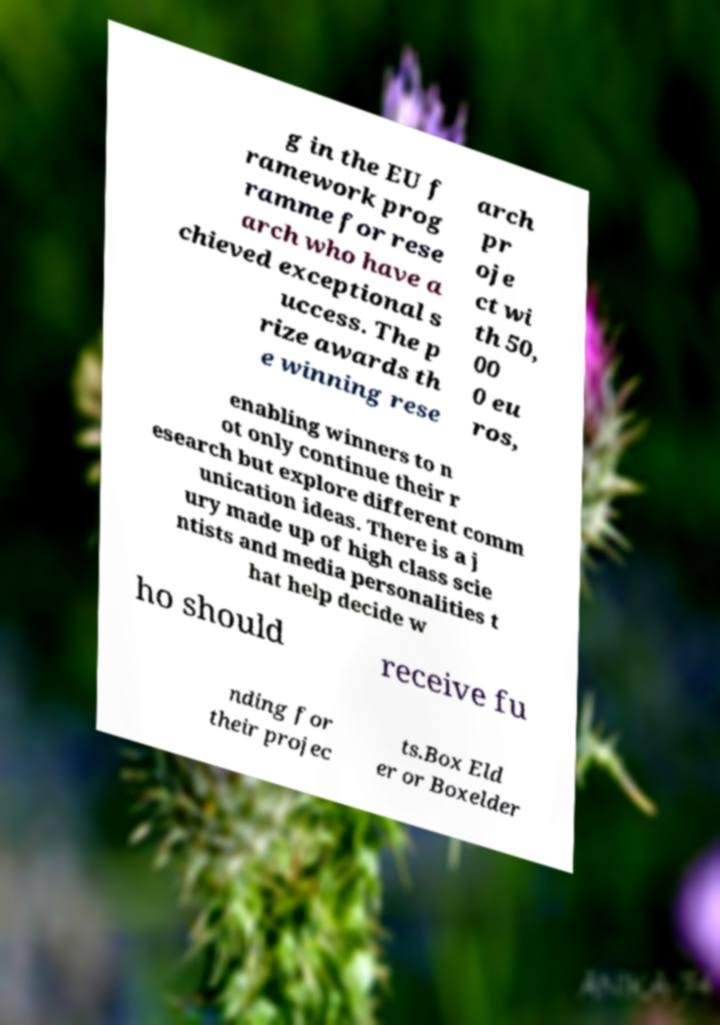Could you assist in decoding the text presented in this image and type it out clearly? g in the EU f ramework prog ramme for rese arch who have a chieved exceptional s uccess. The p rize awards th e winning rese arch pr oje ct wi th 50, 00 0 eu ros, enabling winners to n ot only continue their r esearch but explore different comm unication ideas. There is a j ury made up of high class scie ntists and media personalities t hat help decide w ho should receive fu nding for their projec ts.Box Eld er or Boxelder 